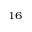<formula> <loc_0><loc_0><loc_500><loc_500>^ { 1 6 }</formula> 